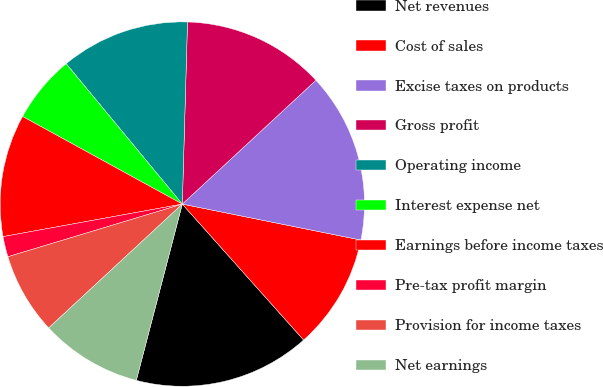Convert chart. <chart><loc_0><loc_0><loc_500><loc_500><pie_chart><fcel>Net revenues<fcel>Cost of sales<fcel>Excise taxes on products<fcel>Gross profit<fcel>Operating income<fcel>Interest expense net<fcel>Earnings before income taxes<fcel>Pre-tax profit margin<fcel>Provision for income taxes<fcel>Net earnings<nl><fcel>15.66%<fcel>10.24%<fcel>15.06%<fcel>12.65%<fcel>11.45%<fcel>6.02%<fcel>10.84%<fcel>1.81%<fcel>7.23%<fcel>9.04%<nl></chart> 